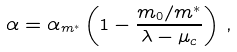<formula> <loc_0><loc_0><loc_500><loc_500>\alpha = \alpha _ { m ^ { * } } \left ( 1 - \frac { m _ { 0 } / m ^ { * } } { \lambda - \mu _ { c } } \right ) \, ,</formula> 